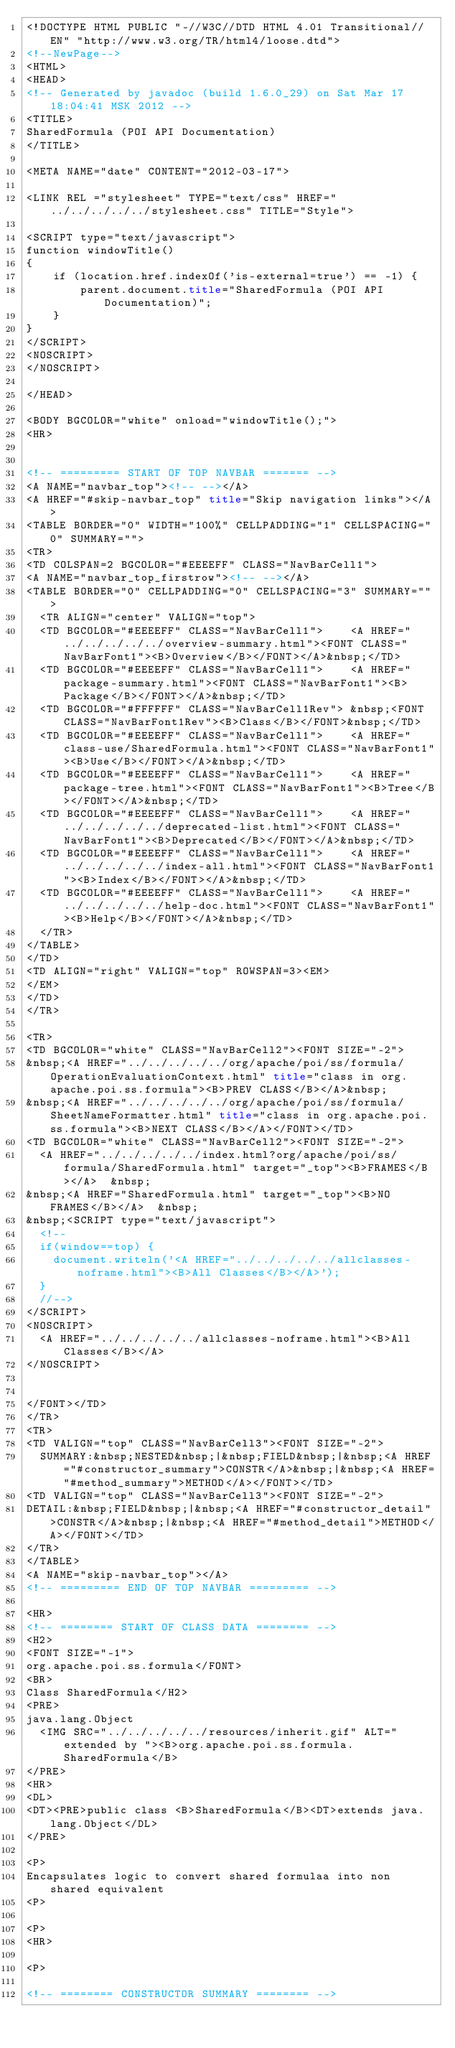<code> <loc_0><loc_0><loc_500><loc_500><_HTML_><!DOCTYPE HTML PUBLIC "-//W3C//DTD HTML 4.01 Transitional//EN" "http://www.w3.org/TR/html4/loose.dtd">
<!--NewPage-->
<HTML>
<HEAD>
<!-- Generated by javadoc (build 1.6.0_29) on Sat Mar 17 18:04:41 MSK 2012 -->
<TITLE>
SharedFormula (POI API Documentation)
</TITLE>

<META NAME="date" CONTENT="2012-03-17">

<LINK REL ="stylesheet" TYPE="text/css" HREF="../../../../../stylesheet.css" TITLE="Style">

<SCRIPT type="text/javascript">
function windowTitle()
{
    if (location.href.indexOf('is-external=true') == -1) {
        parent.document.title="SharedFormula (POI API Documentation)";
    }
}
</SCRIPT>
<NOSCRIPT>
</NOSCRIPT>

</HEAD>

<BODY BGCOLOR="white" onload="windowTitle();">
<HR>


<!-- ========= START OF TOP NAVBAR ======= -->
<A NAME="navbar_top"><!-- --></A>
<A HREF="#skip-navbar_top" title="Skip navigation links"></A>
<TABLE BORDER="0" WIDTH="100%" CELLPADDING="1" CELLSPACING="0" SUMMARY="">
<TR>
<TD COLSPAN=2 BGCOLOR="#EEEEFF" CLASS="NavBarCell1">
<A NAME="navbar_top_firstrow"><!-- --></A>
<TABLE BORDER="0" CELLPADDING="0" CELLSPACING="3" SUMMARY="">
  <TR ALIGN="center" VALIGN="top">
  <TD BGCOLOR="#EEEEFF" CLASS="NavBarCell1">    <A HREF="../../../../../overview-summary.html"><FONT CLASS="NavBarFont1"><B>Overview</B></FONT></A>&nbsp;</TD>
  <TD BGCOLOR="#EEEEFF" CLASS="NavBarCell1">    <A HREF="package-summary.html"><FONT CLASS="NavBarFont1"><B>Package</B></FONT></A>&nbsp;</TD>
  <TD BGCOLOR="#FFFFFF" CLASS="NavBarCell1Rev"> &nbsp;<FONT CLASS="NavBarFont1Rev"><B>Class</B></FONT>&nbsp;</TD>
  <TD BGCOLOR="#EEEEFF" CLASS="NavBarCell1">    <A HREF="class-use/SharedFormula.html"><FONT CLASS="NavBarFont1"><B>Use</B></FONT></A>&nbsp;</TD>
  <TD BGCOLOR="#EEEEFF" CLASS="NavBarCell1">    <A HREF="package-tree.html"><FONT CLASS="NavBarFont1"><B>Tree</B></FONT></A>&nbsp;</TD>
  <TD BGCOLOR="#EEEEFF" CLASS="NavBarCell1">    <A HREF="../../../../../deprecated-list.html"><FONT CLASS="NavBarFont1"><B>Deprecated</B></FONT></A>&nbsp;</TD>
  <TD BGCOLOR="#EEEEFF" CLASS="NavBarCell1">    <A HREF="../../../../../index-all.html"><FONT CLASS="NavBarFont1"><B>Index</B></FONT></A>&nbsp;</TD>
  <TD BGCOLOR="#EEEEFF" CLASS="NavBarCell1">    <A HREF="../../../../../help-doc.html"><FONT CLASS="NavBarFont1"><B>Help</B></FONT></A>&nbsp;</TD>
  </TR>
</TABLE>
</TD>
<TD ALIGN="right" VALIGN="top" ROWSPAN=3><EM>
</EM>
</TD>
</TR>

<TR>
<TD BGCOLOR="white" CLASS="NavBarCell2"><FONT SIZE="-2">
&nbsp;<A HREF="../../../../../org/apache/poi/ss/formula/OperationEvaluationContext.html" title="class in org.apache.poi.ss.formula"><B>PREV CLASS</B></A>&nbsp;
&nbsp;<A HREF="../../../../../org/apache/poi/ss/formula/SheetNameFormatter.html" title="class in org.apache.poi.ss.formula"><B>NEXT CLASS</B></A></FONT></TD>
<TD BGCOLOR="white" CLASS="NavBarCell2"><FONT SIZE="-2">
  <A HREF="../../../../../index.html?org/apache/poi/ss/formula/SharedFormula.html" target="_top"><B>FRAMES</B></A>  &nbsp;
&nbsp;<A HREF="SharedFormula.html" target="_top"><B>NO FRAMES</B></A>  &nbsp;
&nbsp;<SCRIPT type="text/javascript">
  <!--
  if(window==top) {
    document.writeln('<A HREF="../../../../../allclasses-noframe.html"><B>All Classes</B></A>');
  }
  //-->
</SCRIPT>
<NOSCRIPT>
  <A HREF="../../../../../allclasses-noframe.html"><B>All Classes</B></A>
</NOSCRIPT>


</FONT></TD>
</TR>
<TR>
<TD VALIGN="top" CLASS="NavBarCell3"><FONT SIZE="-2">
  SUMMARY:&nbsp;NESTED&nbsp;|&nbsp;FIELD&nbsp;|&nbsp;<A HREF="#constructor_summary">CONSTR</A>&nbsp;|&nbsp;<A HREF="#method_summary">METHOD</A></FONT></TD>
<TD VALIGN="top" CLASS="NavBarCell3"><FONT SIZE="-2">
DETAIL:&nbsp;FIELD&nbsp;|&nbsp;<A HREF="#constructor_detail">CONSTR</A>&nbsp;|&nbsp;<A HREF="#method_detail">METHOD</A></FONT></TD>
</TR>
</TABLE>
<A NAME="skip-navbar_top"></A>
<!-- ========= END OF TOP NAVBAR ========= -->

<HR>
<!-- ======== START OF CLASS DATA ======== -->
<H2>
<FONT SIZE="-1">
org.apache.poi.ss.formula</FONT>
<BR>
Class SharedFormula</H2>
<PRE>
java.lang.Object
  <IMG SRC="../../../../../resources/inherit.gif" ALT="extended by "><B>org.apache.poi.ss.formula.SharedFormula</B>
</PRE>
<HR>
<DL>
<DT><PRE>public class <B>SharedFormula</B><DT>extends java.lang.Object</DL>
</PRE>

<P>
Encapsulates logic to convert shared formulaa into non shared equivalent
<P>

<P>
<HR>

<P>

<!-- ======== CONSTRUCTOR SUMMARY ======== -->
</code> 